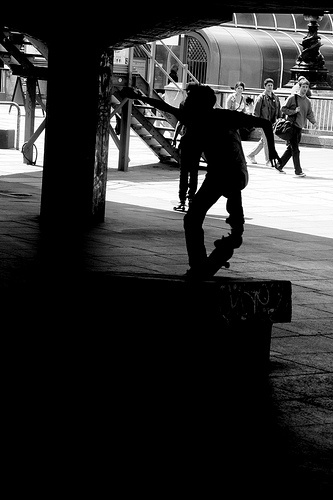Describe the objects in this image and their specific colors. I can see people in black, gray, darkgray, and white tones, bench in black and gray tones, people in black, gray, darkgray, and lightgray tones, people in black, gray, darkgray, and lightgray tones, and people in black, gray, darkgray, and lightgray tones in this image. 